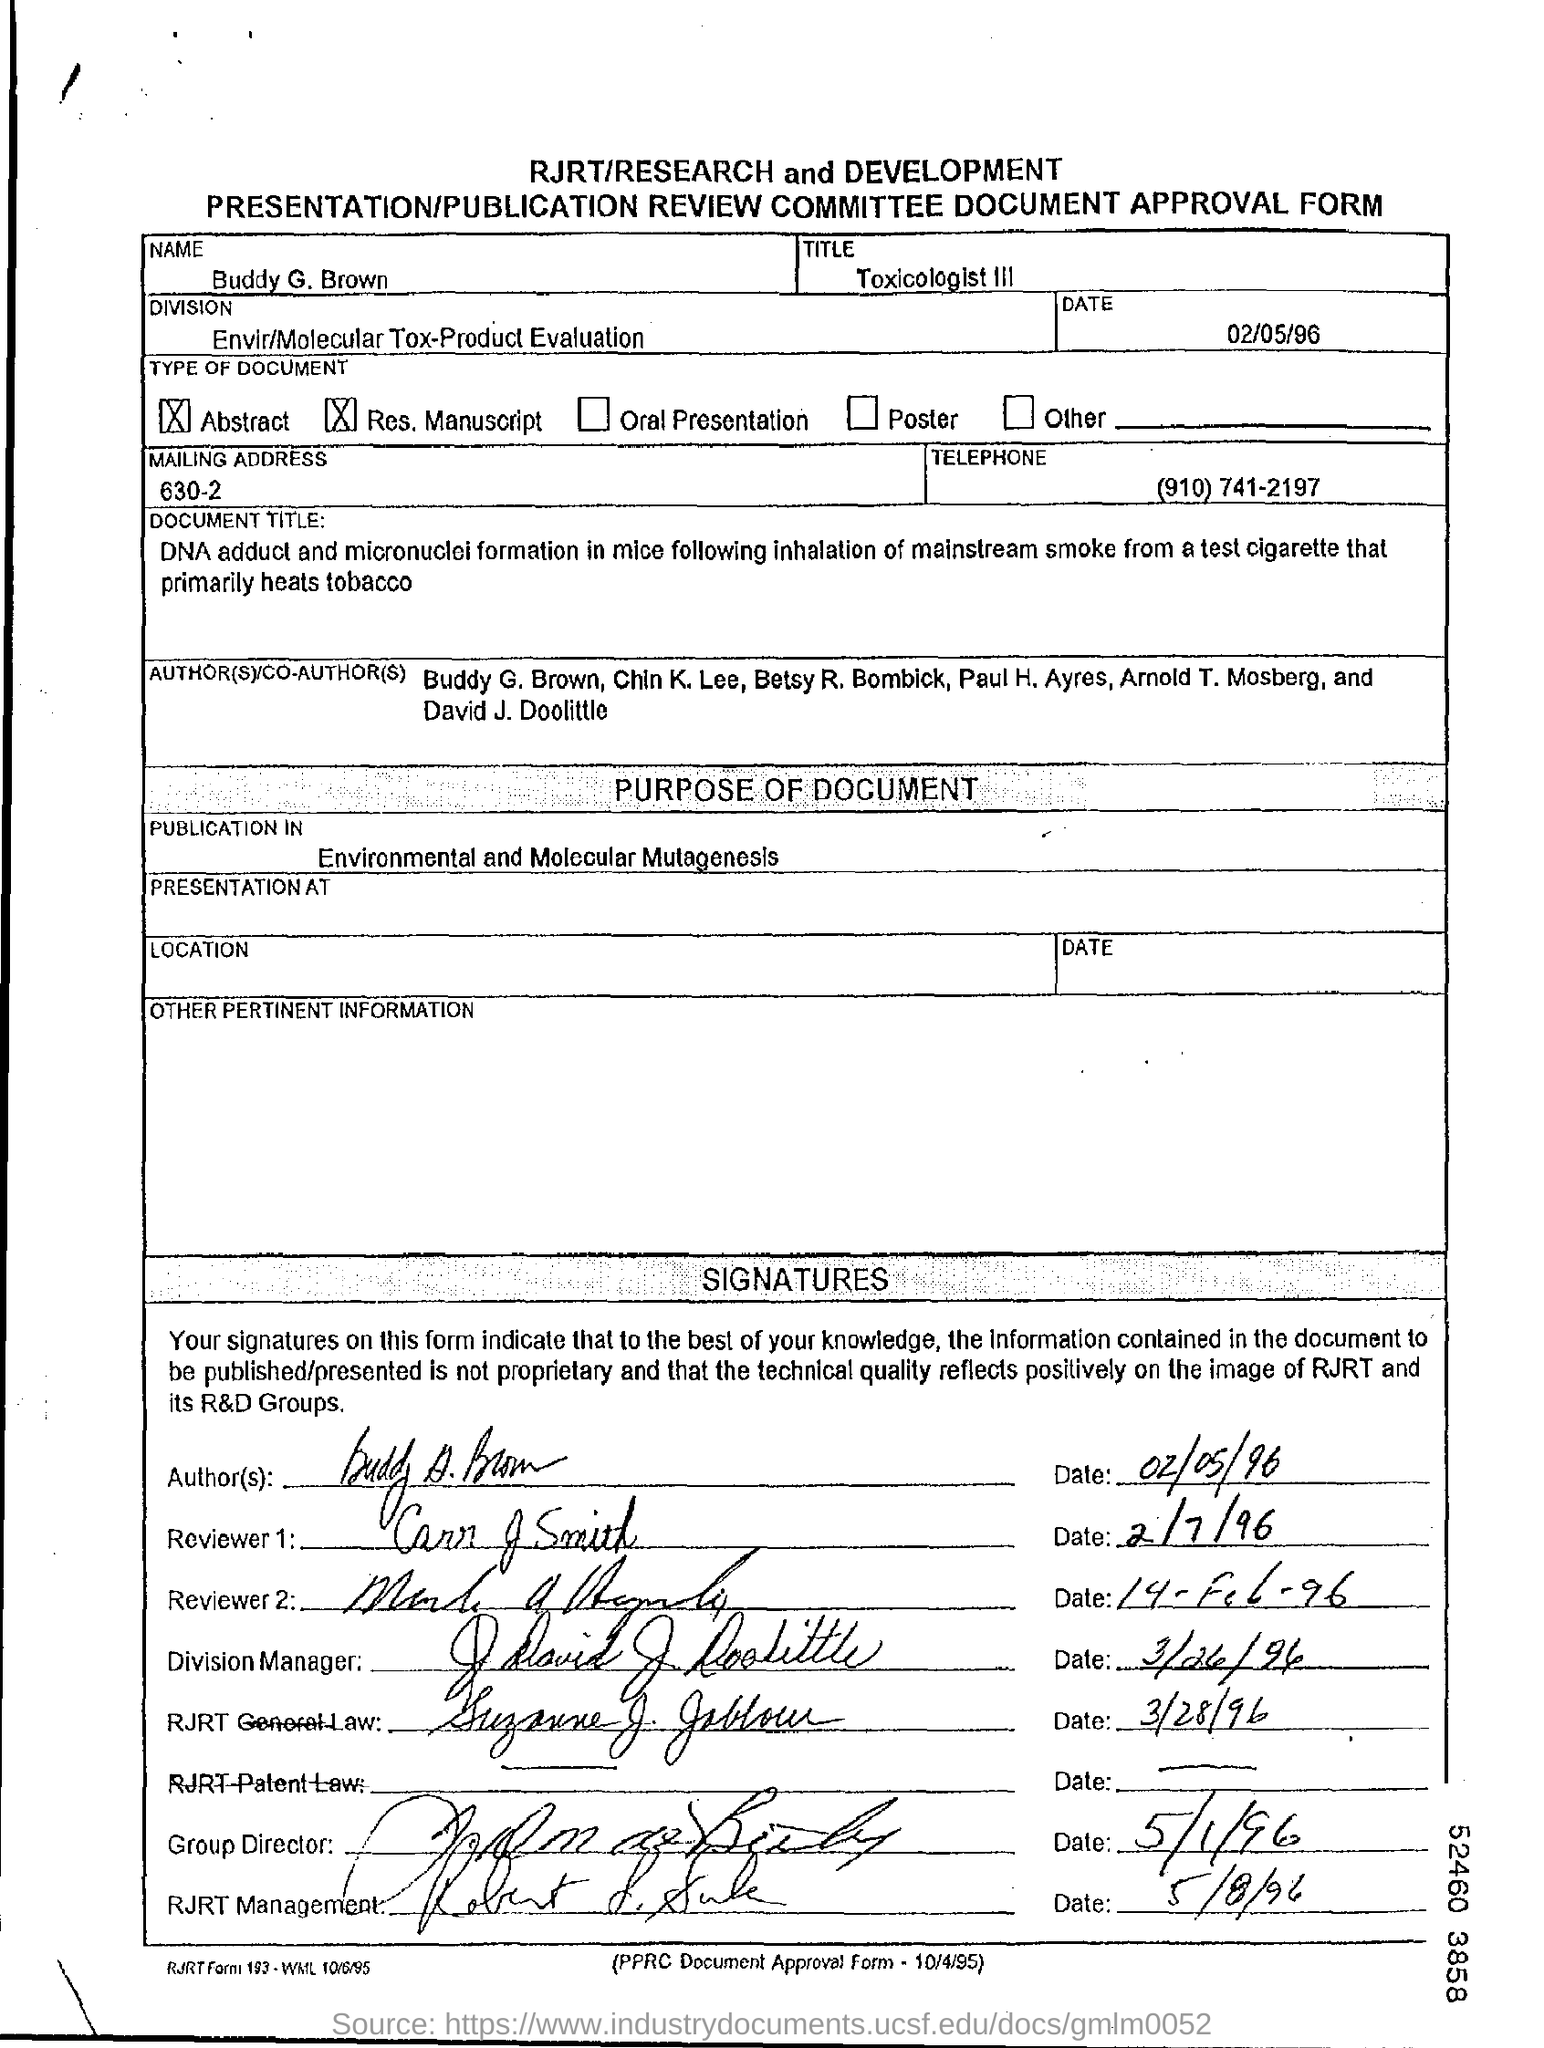Mention a couple of crucial points in this snapshot. Buddy holds the title of Toxicologist III. The mentioned division is "Envir/Molecular Tox-Product Evaluation. The name given is Buddy G. Brown. The document was published in the journal Environmental and Molecular Mutagenesis. The form is dated as of 02/05/96. 